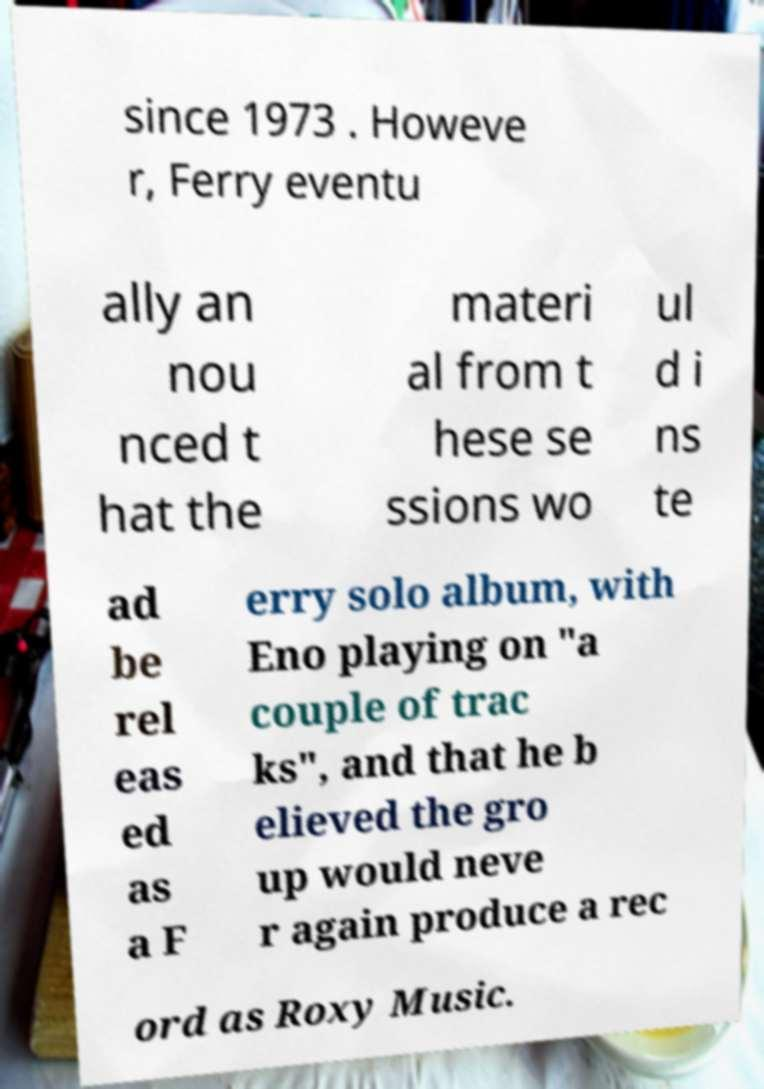There's text embedded in this image that I need extracted. Can you transcribe it verbatim? since 1973 . Howeve r, Ferry eventu ally an nou nced t hat the materi al from t hese se ssions wo ul d i ns te ad be rel eas ed as a F erry solo album, with Eno playing on "a couple of trac ks", and that he b elieved the gro up would neve r again produce a rec ord as Roxy Music. 